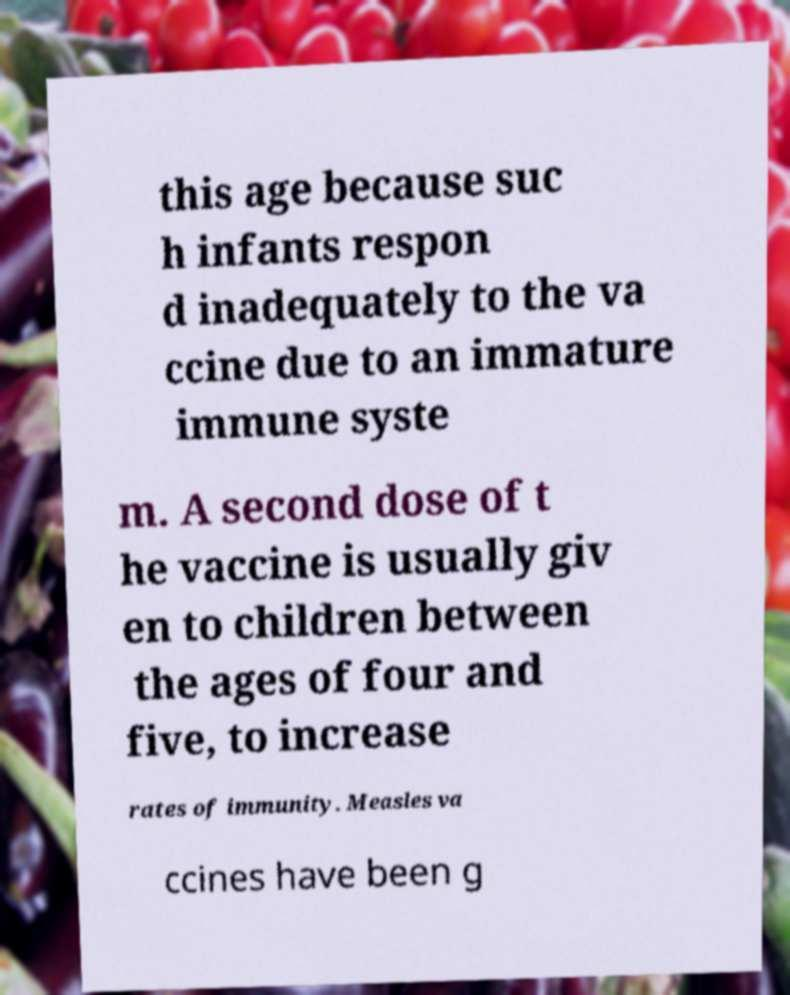Please identify and transcribe the text found in this image. this age because suc h infants respon d inadequately to the va ccine due to an immature immune syste m. A second dose of t he vaccine is usually giv en to children between the ages of four and five, to increase rates of immunity. Measles va ccines have been g 